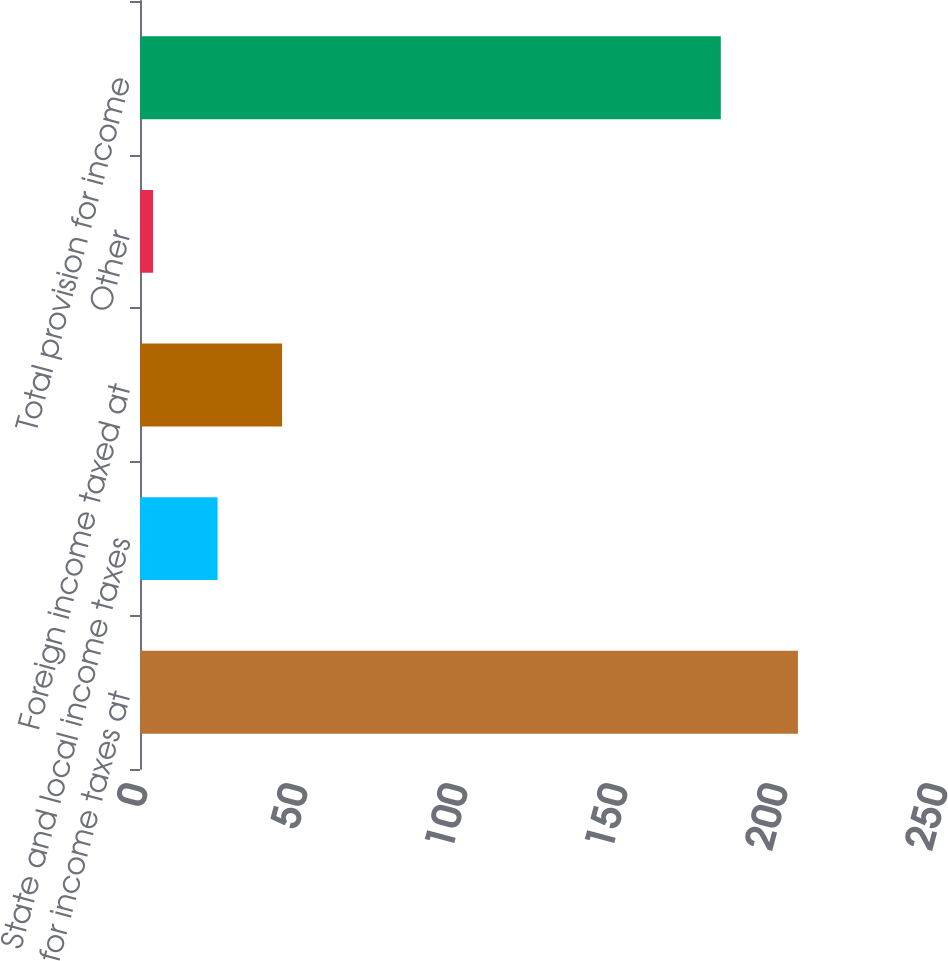Convert chart. <chart><loc_0><loc_0><loc_500><loc_500><bar_chart><fcel>Provision for income taxes at<fcel>State and local income taxes<fcel>Foreign income taxed at<fcel>Other<fcel>Total provision for income<nl><fcel>205.6<fcel>24.25<fcel>44.4<fcel>4.1<fcel>181.5<nl></chart> 